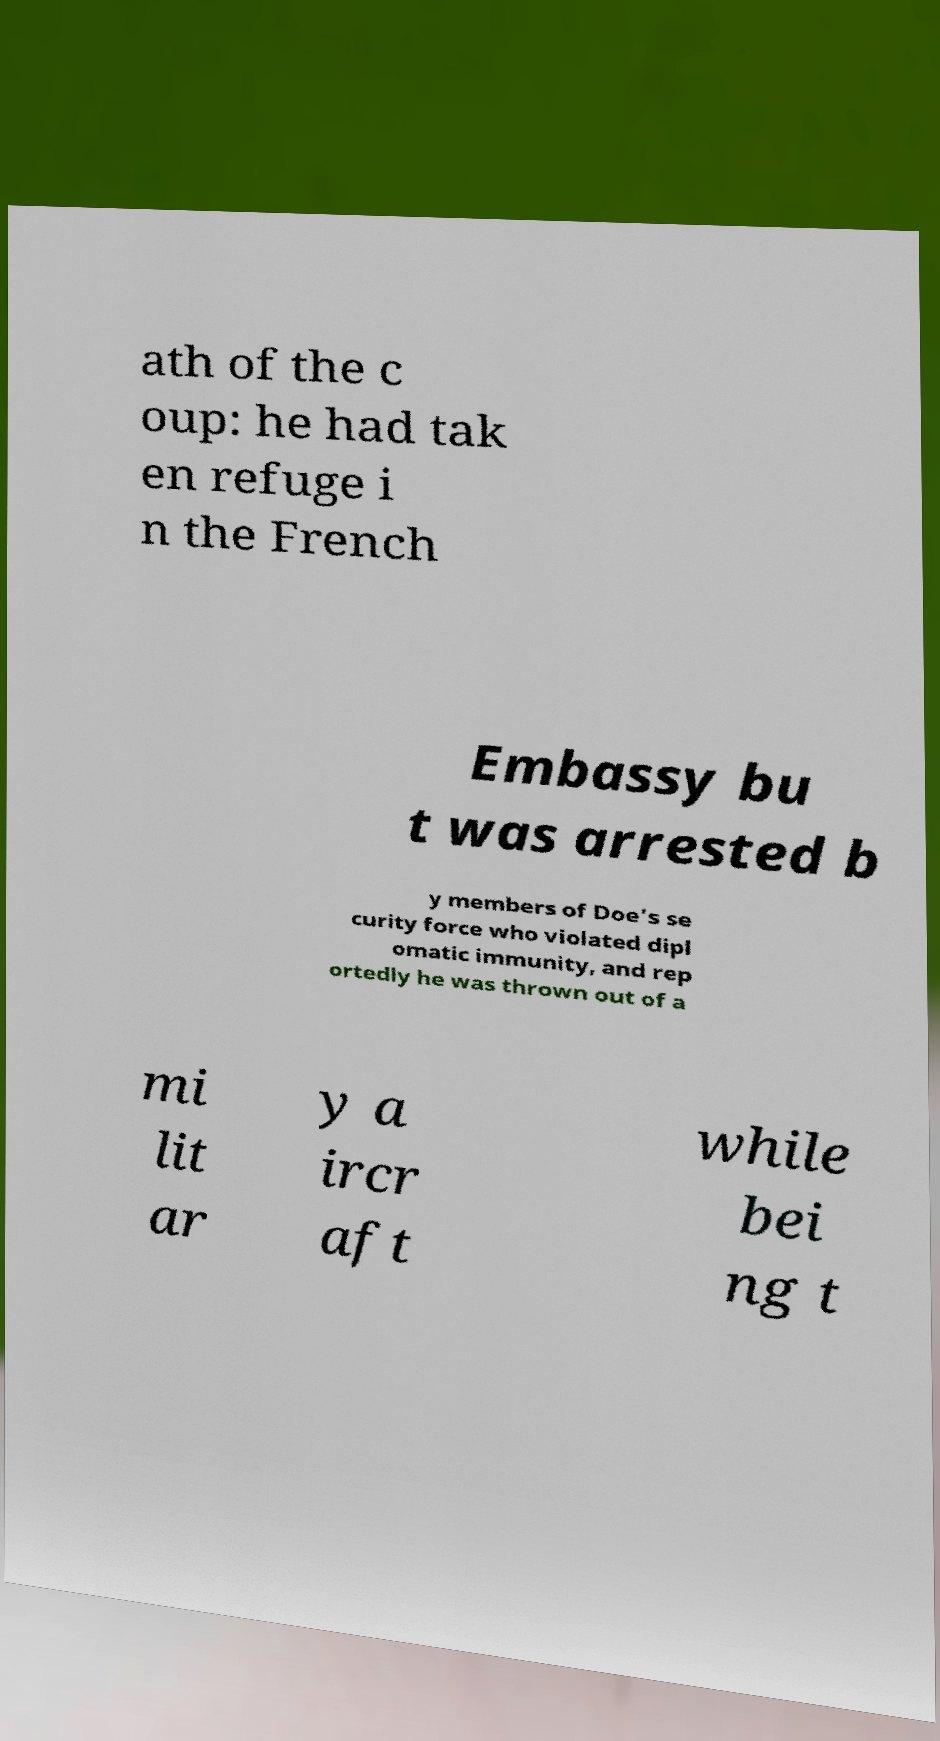For documentation purposes, I need the text within this image transcribed. Could you provide that? ath of the c oup: he had tak en refuge i n the French Embassy bu t was arrested b y members of Doe's se curity force who violated dipl omatic immunity, and rep ortedly he was thrown out of a mi lit ar y a ircr aft while bei ng t 